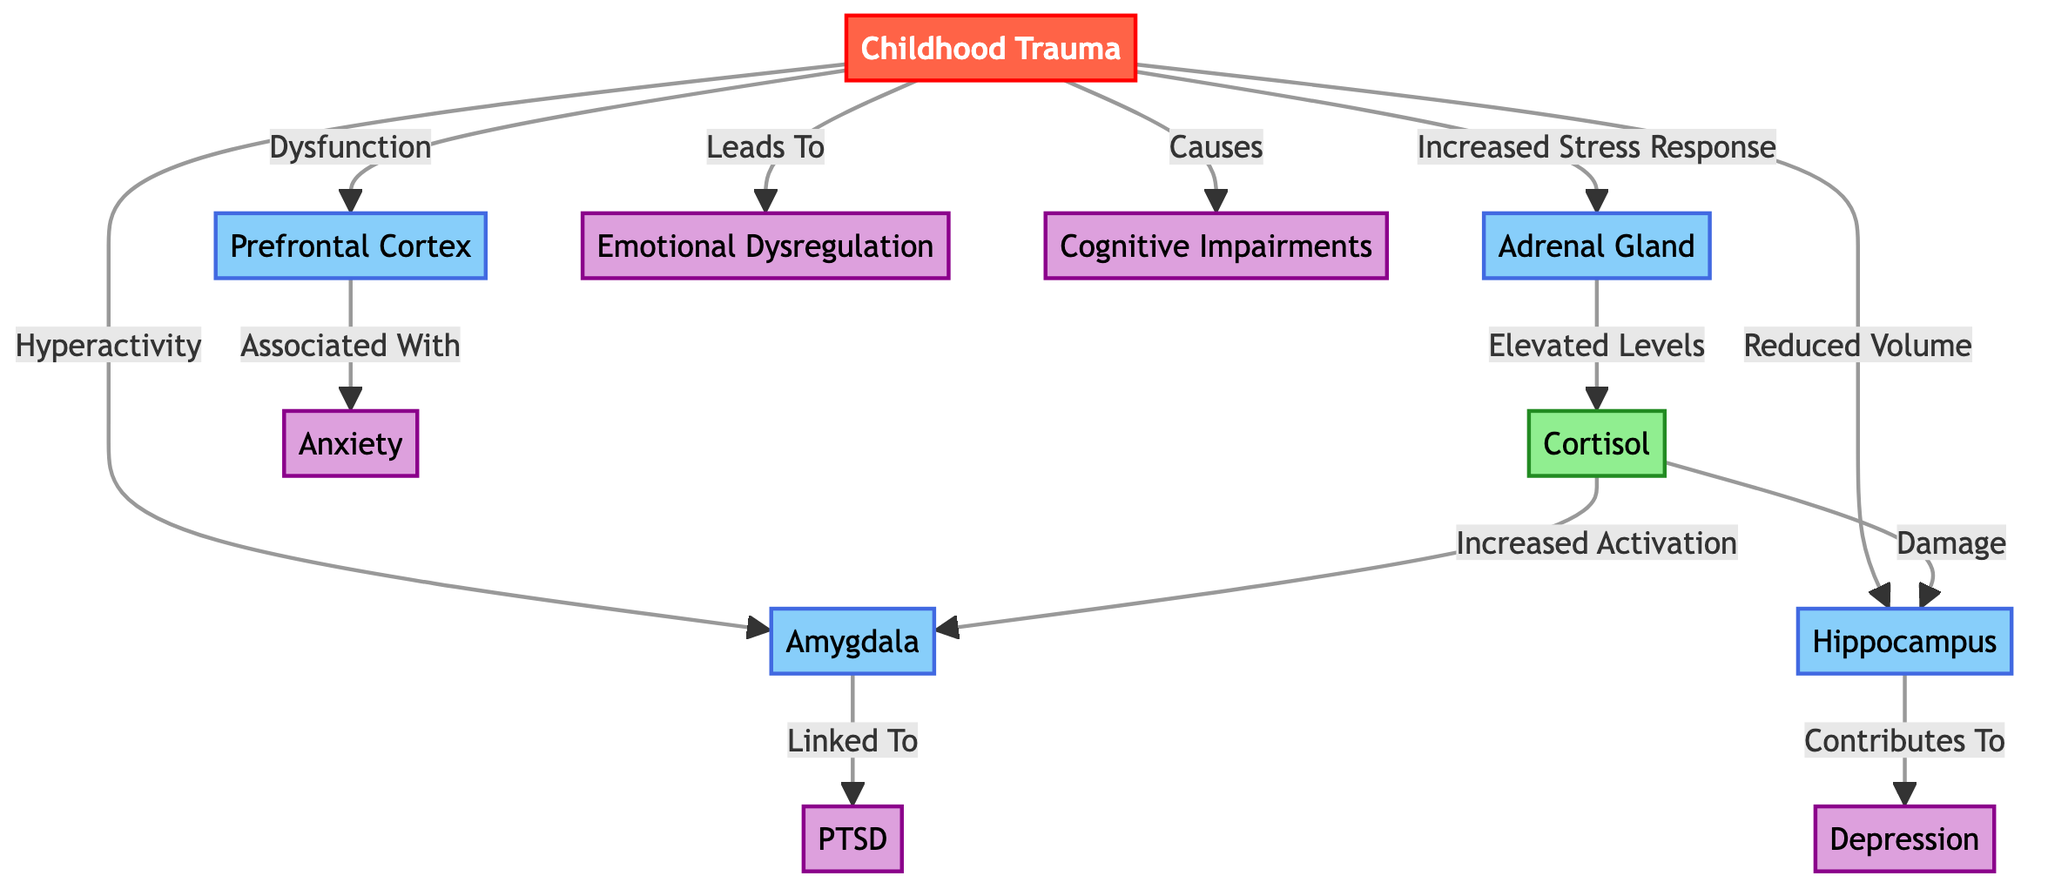What node represents childhood trauma? The starting point of the diagram is labeled "Childhood Trauma," which is the main factor influencing various brain changes and psychological outcomes.
Answer: Childhood Trauma Which brain region is associated with hyperactivity? The diagram indicates an arrow from "Childhood Trauma" to "Amygdala," with the annotation "Hyperactivity," signifying that hyperactivity is linked to changes in this region due to trauma.
Answer: Amygdala How many psychological disorders are mentioned in the diagram? There are five disorders listed: PTSD, Depression, Anxiety, Emotional Dysregulation, and Cognitive Impairments. Adding these gives a total of five disorders shown in the diagram.
Answer: 5 What physiological change is linked to the adrenal gland? The diagram conveys that the adrenal gland experiences "Increased Stress Response" as a result of childhood trauma, indicating an elevation in stress response mechanisms.
Answer: Increased Stress Response What is the effect of cortisol on the amygdala? The diagram shows a connection indicating that cortisol leads to "Increased Activation" of the amygdala, meaning that elevated cortisol levels enhance the activity of this brain region.
Answer: Increased Activation Which psychological disorder is associated with the hippocampus? The diagram indicates that the hippocampus contributes to "Depression," meaning changes in this brain area are linked to depressive symptoms.
Answer: Depression How does childhood trauma affect the prefrontal cortex? The diagram specifies that childhood trauma results in "Dysfunction" of the prefrontal cortex, suggesting impairments in executive functions and emotional control.
Answer: Dysfunction What is the impact of cortisol on the hippocampus? According to the diagram, cortisol is shown to cause "Damage" to the hippocampus, highlighting that elevated stress hormones can negatively affect this brain structure.
Answer: Damage Which region is linked to anxiety? The diagram indicates that the "Prefrontal Cortex" is associated with anxiety, suggesting this area's role in the regulation of anxious responses.
Answer: Prefrontal Cortex 